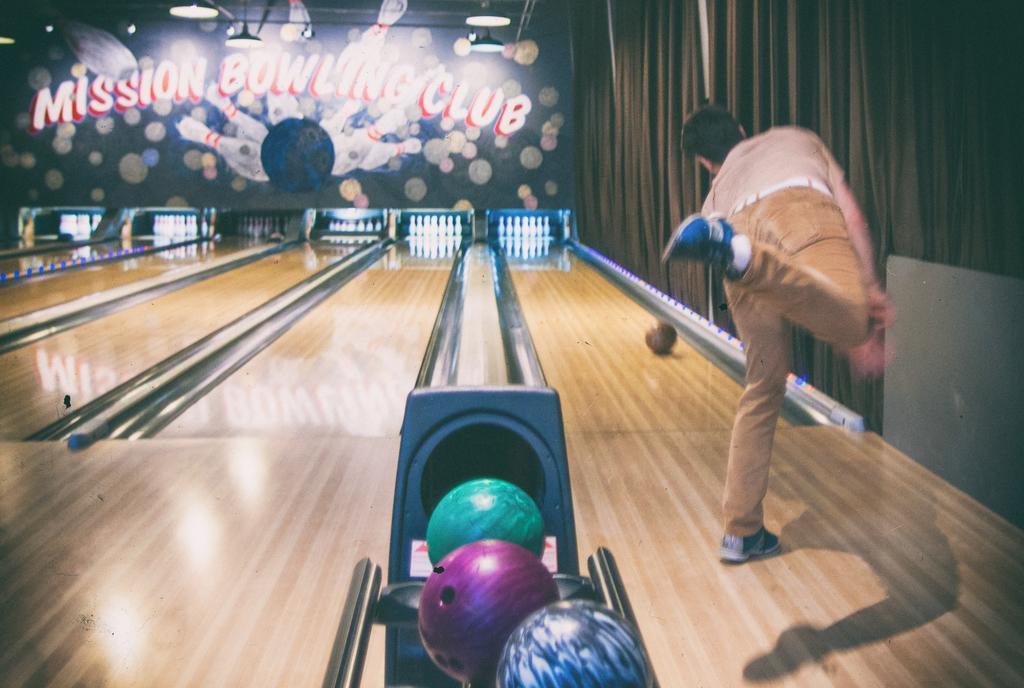Could you give a brief overview of what you see in this image? In this picture we can see a man is playing bowling game, beside to him we can find few bowling balls, in the background we can see few pins and lights, and also we can see curtains. 